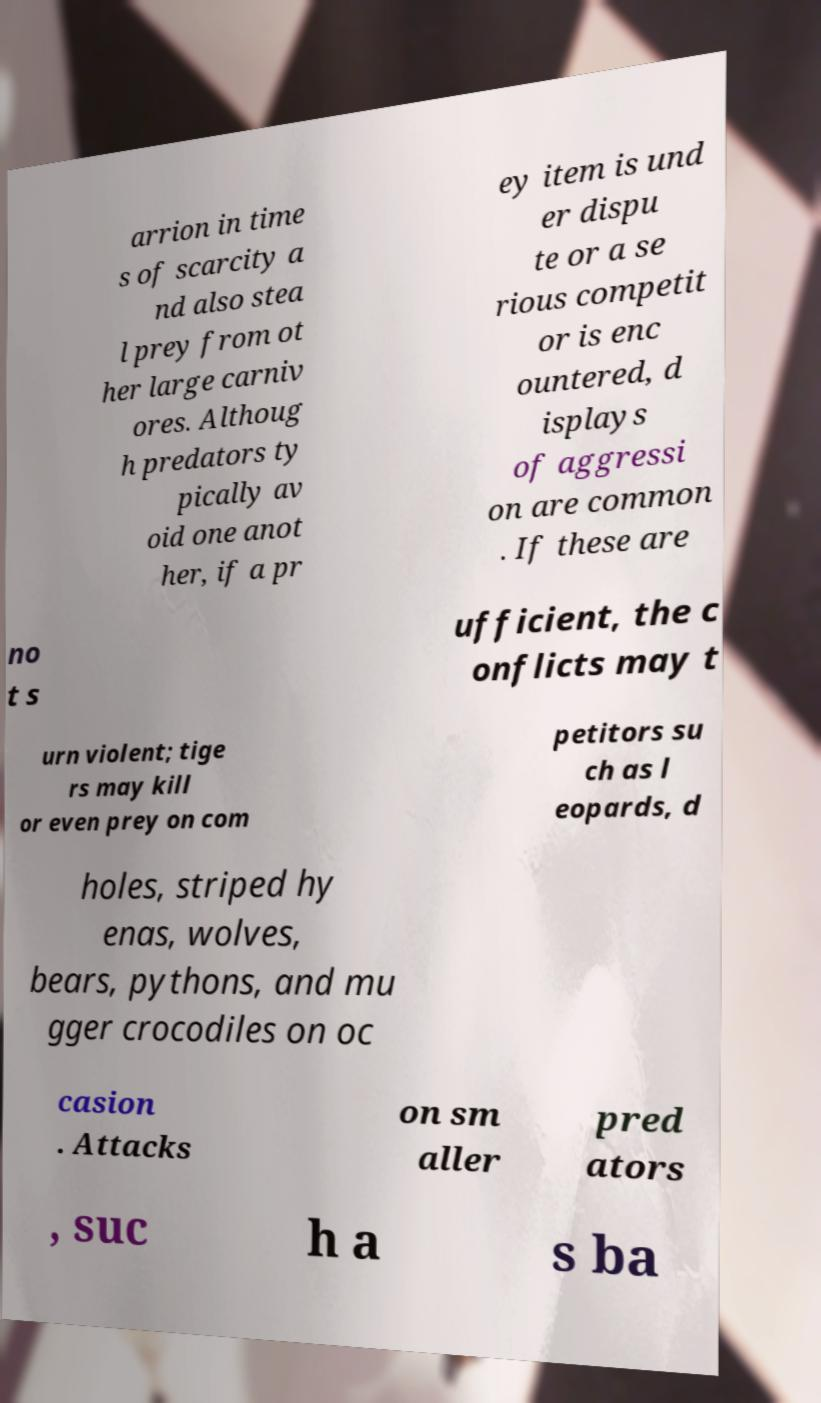I need the written content from this picture converted into text. Can you do that? arrion in time s of scarcity a nd also stea l prey from ot her large carniv ores. Althoug h predators ty pically av oid one anot her, if a pr ey item is und er dispu te or a se rious competit or is enc ountered, d isplays of aggressi on are common . If these are no t s ufficient, the c onflicts may t urn violent; tige rs may kill or even prey on com petitors su ch as l eopards, d holes, striped hy enas, wolves, bears, pythons, and mu gger crocodiles on oc casion . Attacks on sm aller pred ators , suc h a s ba 